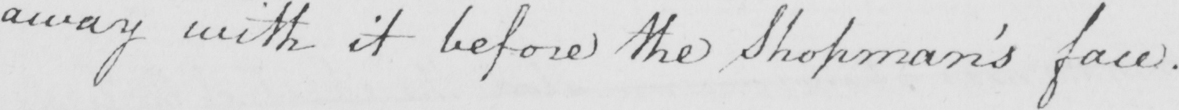Can you read and transcribe this handwriting? away with it before the Shopman ' s face . 